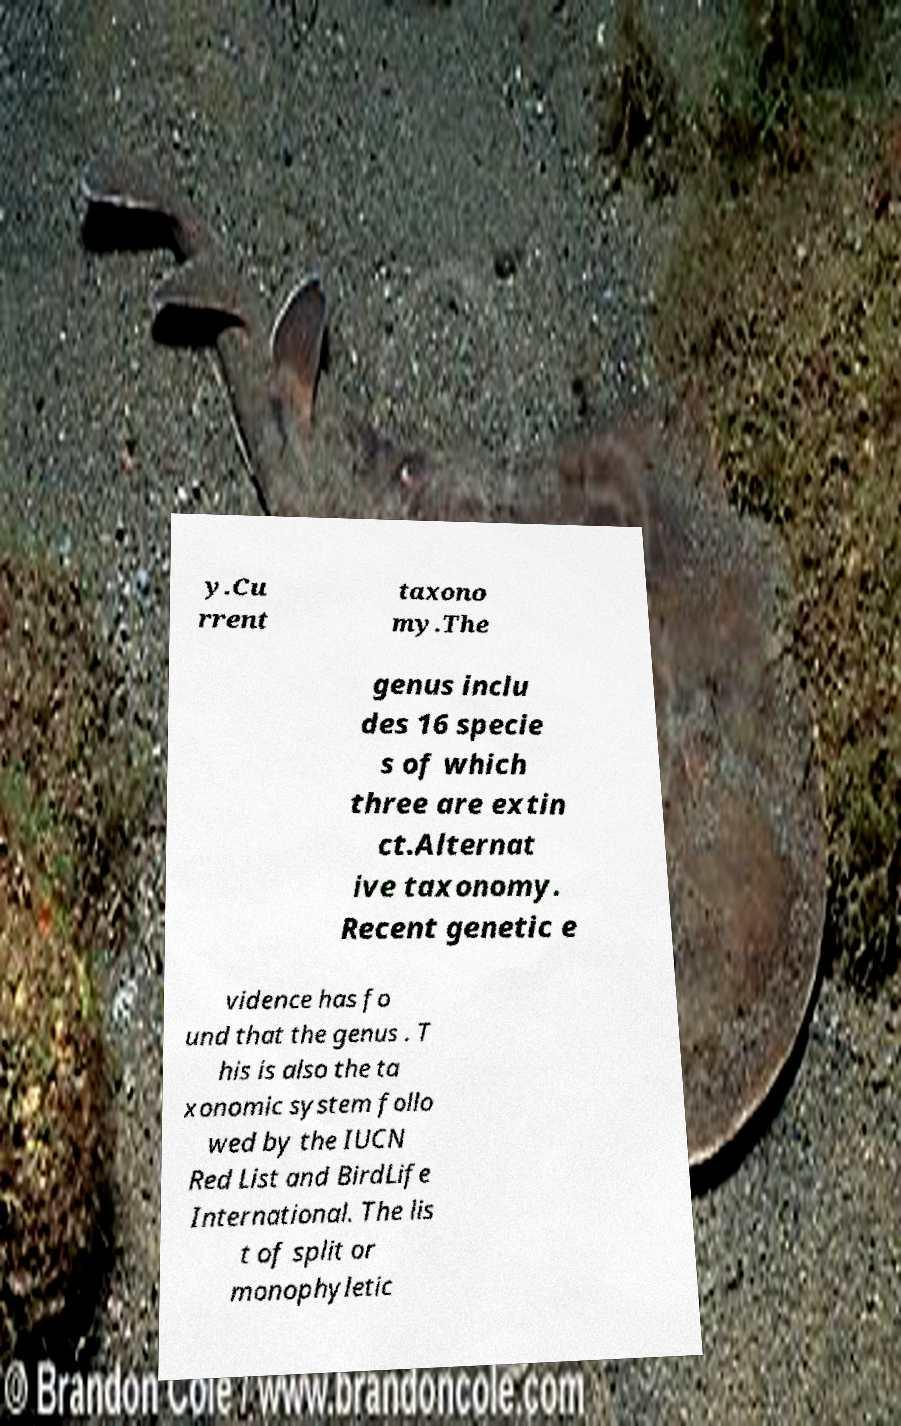There's text embedded in this image that I need extracted. Can you transcribe it verbatim? y.Cu rrent taxono my.The genus inclu des 16 specie s of which three are extin ct.Alternat ive taxonomy. Recent genetic e vidence has fo und that the genus . T his is also the ta xonomic system follo wed by the IUCN Red List and BirdLife International. The lis t of split or monophyletic 